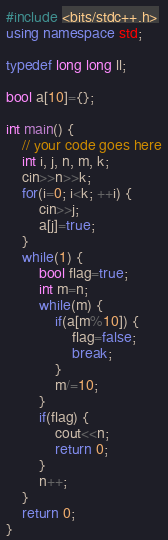<code> <loc_0><loc_0><loc_500><loc_500><_C++_>#include <bits/stdc++.h>
using namespace std;

typedef long long ll;

bool a[10]={};

int main() {
	// your code goes here
	int i, j, n, m, k;
	cin>>n>>k;
	for(i=0; i<k; ++i) {
		cin>>j;
		a[j]=true;
	}
	while(1) {
		bool flag=true;
		int m=n;
		while(m) {
			if(a[m%10]) {
				flag=false;
				break;
			}
			m/=10;
		}
		if(flag) {
			cout<<n;
			return 0;
		}
		n++;
	}
	return 0;
}</code> 